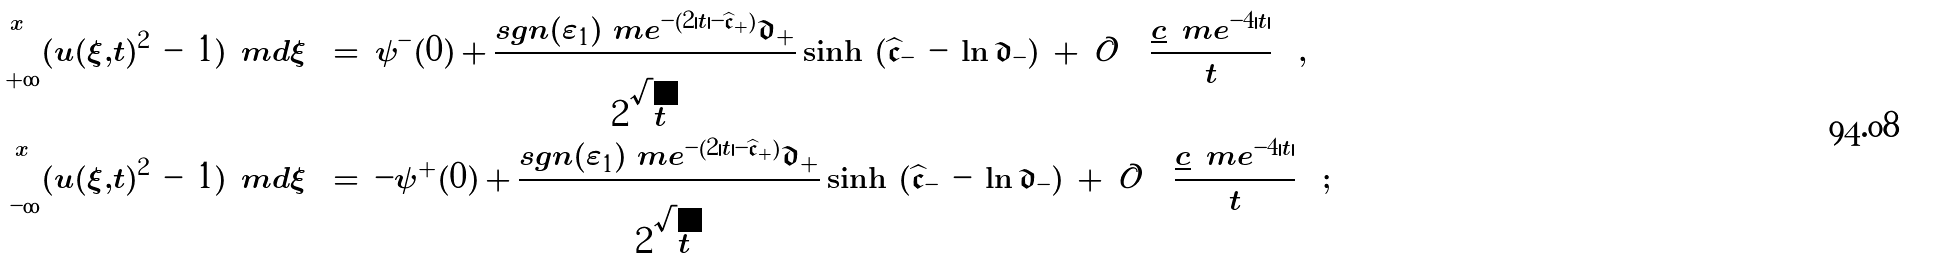Convert formula to latex. <formula><loc_0><loc_0><loc_500><loc_500>\int \nolimits _ { + \infty } ^ { x } ( | u ( \xi , t ) | ^ { 2 } \, - \, 1 ) \, \ m d \xi \, & = \, \psi ^ { - } ( 0 ) \, + \, \frac { s g n ( \varepsilon _ { 1 } ) \ m e ^ { - ( 2 | t | - \widehat { \mathfrak { c } } _ { + } ) } \mathfrak { d } _ { + } } { 2 \sqrt { | t | } } \sinh \, \left ( \widehat { \mathfrak { c } } _ { - } \, - \, \ln \mathfrak { d } _ { - } \right ) \, + \, \mathcal { O } \, \left ( \frac { \underline { c } \, \ m e ^ { - 4 | t | } } { t } \right ) , \\ \int \nolimits _ { - \infty } ^ { x } ( | u ( \xi , t ) | ^ { 2 } \, - \, 1 ) \, \ m d \xi \, & = \, - \psi ^ { + } ( 0 ) \, + \, \frac { s g n ( \varepsilon _ { 1 } ) \ m e ^ { - ( 2 | t | - \widehat { \mathfrak { c } } _ { + } ) } \mathfrak { d } _ { + } } { 2 \sqrt { | t | } } \sinh \, \left ( \widehat { \mathfrak { c } } _ { - } \, - \, \ln \mathfrak { d } _ { - } \right ) \, + \, \mathcal { O } \, \left ( \frac { \underline { c } \, \ m e ^ { - 4 | t | } } { t } \right ) ;</formula> 